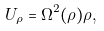Convert formula to latex. <formula><loc_0><loc_0><loc_500><loc_500>U _ { \rho } = \Omega ^ { 2 } ( \rho ) \rho ,</formula> 